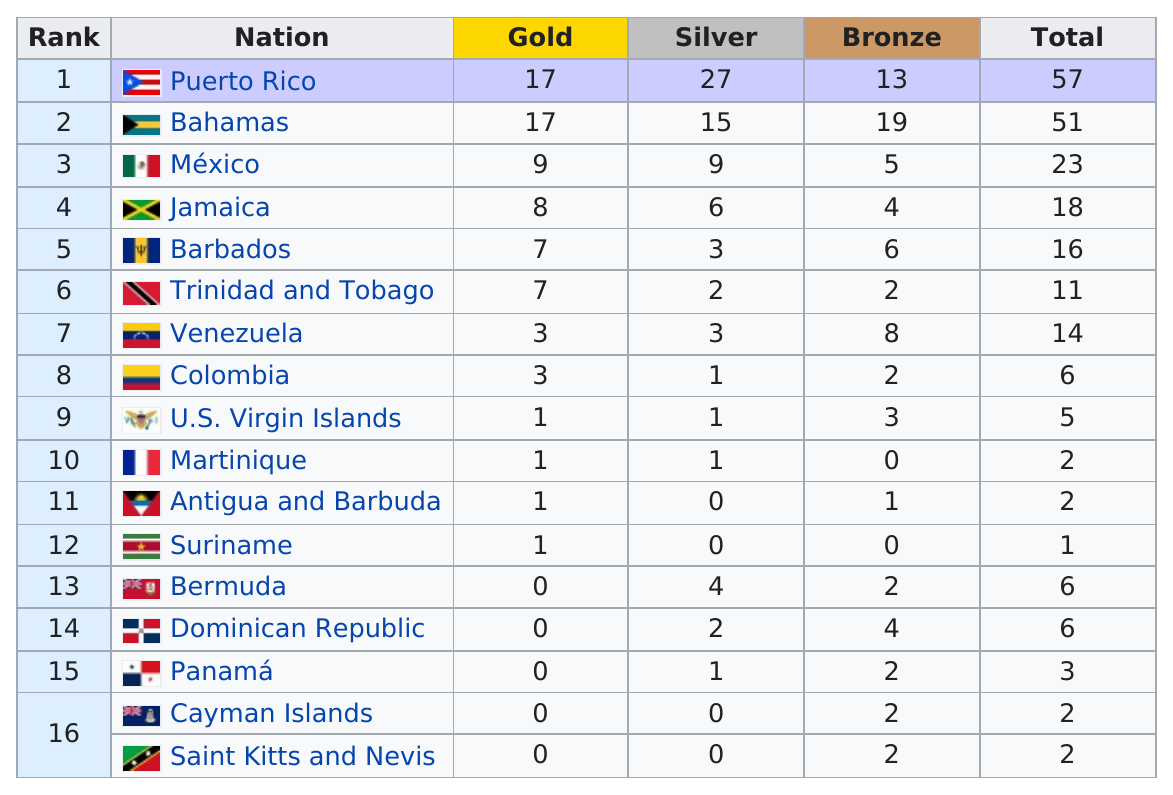Draw attention to some important aspects in this diagram. Mexico has won more gold medals than Jamaica in their respective Olympic Games histories. The countries of Puerto Rico, the Bahamas, Mexico, and Jamaica have all won at least five silver medals in various international competitions. Venezuela placed seventh in the overall medal count, with Colombia following closely behind. Bermuda has won a total of 4 silver medals. Puerto Rico won the most silver medals among all countries in a certain competition. 